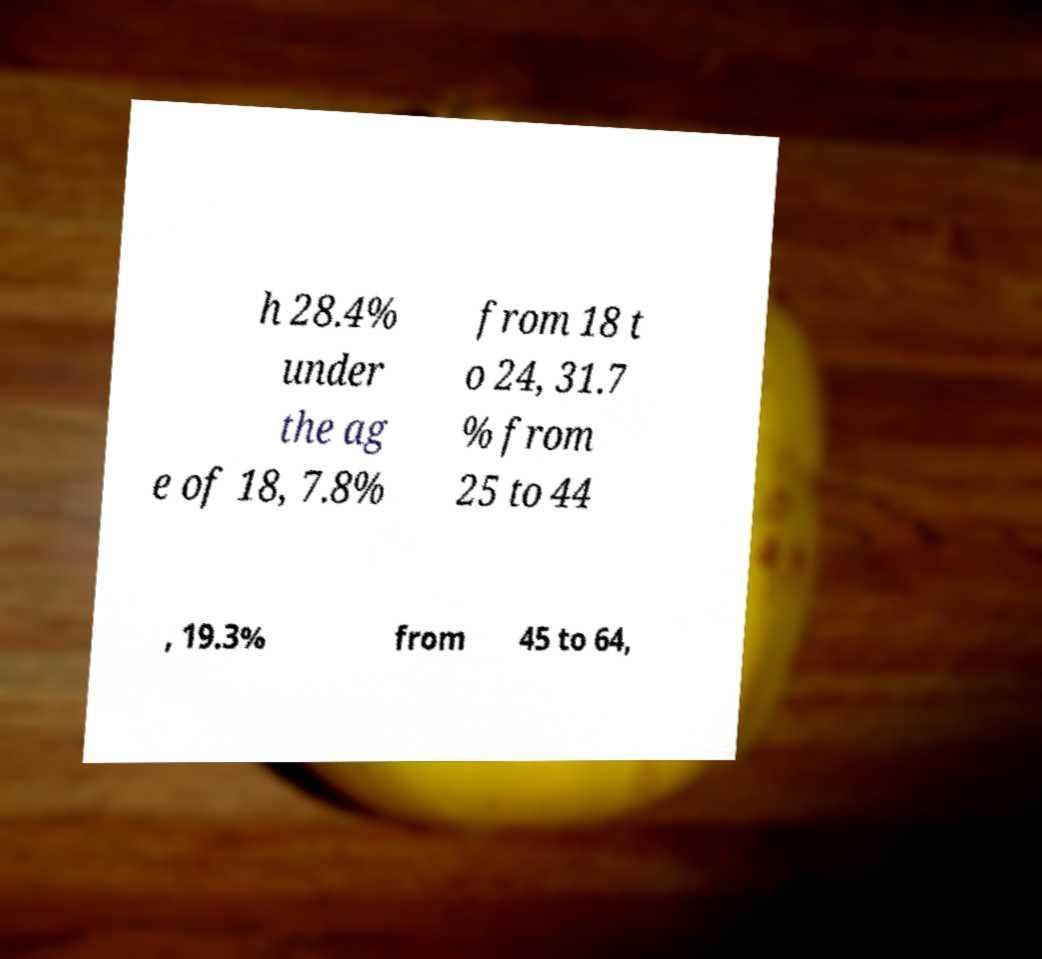For documentation purposes, I need the text within this image transcribed. Could you provide that? h 28.4% under the ag e of 18, 7.8% from 18 t o 24, 31.7 % from 25 to 44 , 19.3% from 45 to 64, 